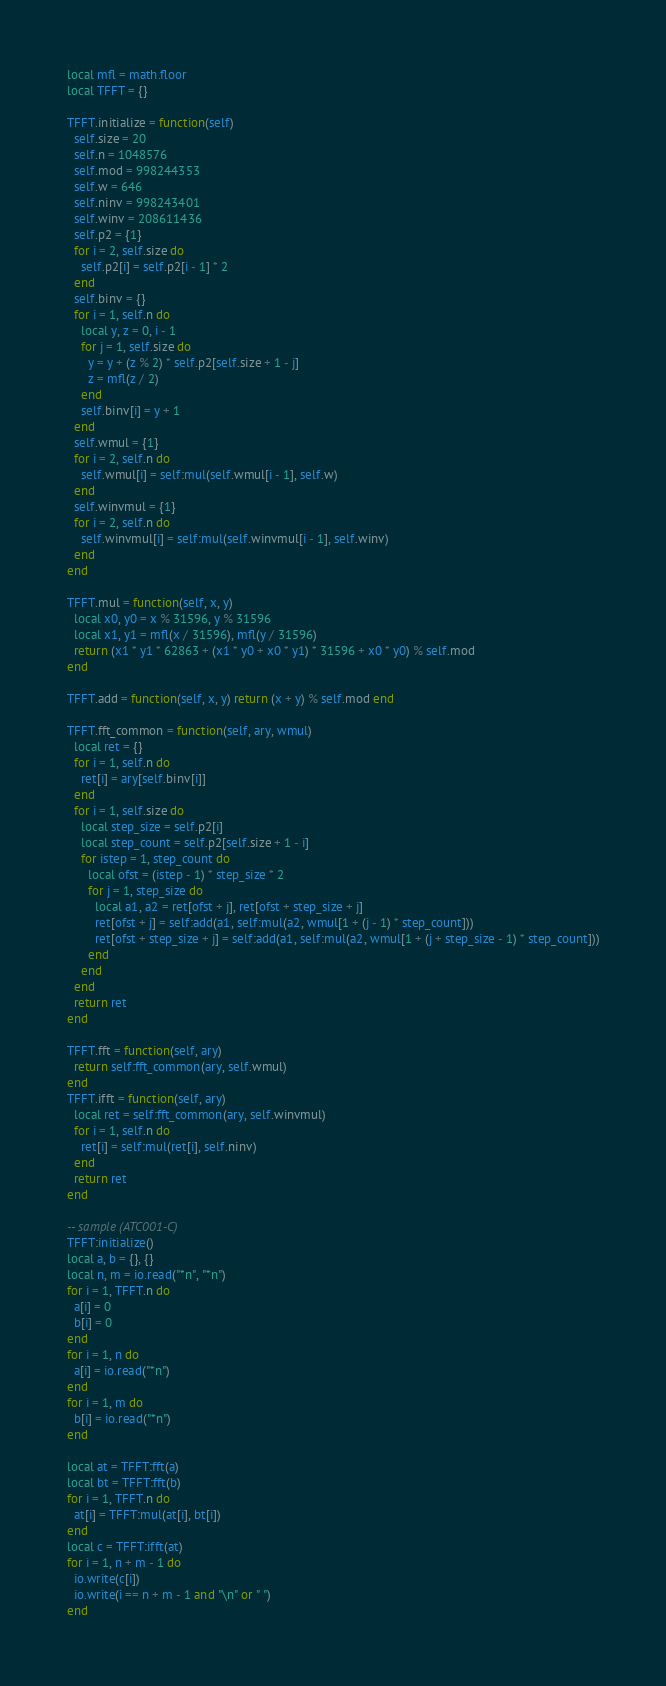<code> <loc_0><loc_0><loc_500><loc_500><_Lua_>local mfl = math.floor
local TFFT = {}

TFFT.initialize = function(self)
  self.size = 20
  self.n = 1048576
  self.mod = 998244353
  self.w = 646
  self.ninv = 998243401
  self.winv = 208611436
  self.p2 = {1}
  for i = 2, self.size do
    self.p2[i] = self.p2[i - 1] * 2
  end
  self.binv = {}
  for i = 1, self.n do
    local y, z = 0, i - 1
    for j = 1, self.size do
      y = y + (z % 2) * self.p2[self.size + 1 - j]
      z = mfl(z / 2)
    end
    self.binv[i] = y + 1
  end
  self.wmul = {1}
  for i = 2, self.n do
    self.wmul[i] = self:mul(self.wmul[i - 1], self.w)
  end
  self.winvmul = {1}
  for i = 2, self.n do
    self.winvmul[i] = self:mul(self.winvmul[i - 1], self.winv)
  end
end

TFFT.mul = function(self, x, y)
  local x0, y0 = x % 31596, y % 31596
  local x1, y1 = mfl(x / 31596), mfl(y / 31596)
  return (x1 * y1 * 62863 + (x1 * y0 + x0 * y1) * 31596 + x0 * y0) % self.mod
end

TFFT.add = function(self, x, y) return (x + y) % self.mod end

TFFT.fft_common = function(self, ary, wmul)
  local ret = {}
  for i = 1, self.n do
    ret[i] = ary[self.binv[i]]
  end
  for i = 1, self.size do
    local step_size = self.p2[i]
    local step_count = self.p2[self.size + 1 - i]
    for istep = 1, step_count do
      local ofst = (istep - 1) * step_size * 2
      for j = 1, step_size do
        local a1, a2 = ret[ofst + j], ret[ofst + step_size + j]
        ret[ofst + j] = self:add(a1, self:mul(a2, wmul[1 + (j - 1) * step_count]))
        ret[ofst + step_size + j] = self:add(a1, self:mul(a2, wmul[1 + (j + step_size - 1) * step_count]))
      end
    end
  end
  return ret
end

TFFT.fft = function(self, ary)
  return self:fft_common(ary, self.wmul)
end
TFFT.ifft = function(self, ary)
  local ret = self:fft_common(ary, self.winvmul)
  for i = 1, self.n do
    ret[i] = self:mul(ret[i], self.ninv)
  end
  return ret
end

-- sample (ATC001-C)
TFFT:initialize()
local a, b = {}, {}
local n, m = io.read("*n", "*n")
for i = 1, TFFT.n do
  a[i] = 0
  b[i] = 0
end
for i = 1, n do
  a[i] = io.read("*n")
end
for i = 1, m do
  b[i] = io.read("*n")
end

local at = TFFT:fft(a)
local bt = TFFT:fft(b)
for i = 1, TFFT.n do
  at[i] = TFFT:mul(at[i], bt[i])
end
local c = TFFT:ifft(at)
for i = 1, n + m - 1 do
  io.write(c[i])
  io.write(i == n + m - 1 and "\n" or " ")
end
</code> 